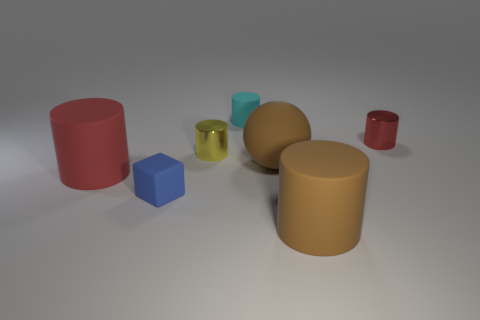The thing that is the same color as the matte ball is what shape? The object sharing the same matte color as the spherical ball is shaped as a cylinder. 